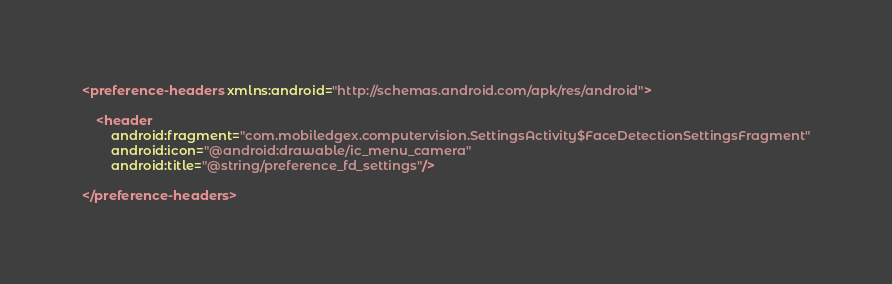<code> <loc_0><loc_0><loc_500><loc_500><_XML_><preference-headers xmlns:android="http://schemas.android.com/apk/res/android">

    <header
        android:fragment="com.mobiledgex.computervision.SettingsActivity$FaceDetectionSettingsFragment"
        android:icon="@android:drawable/ic_menu_camera"
        android:title="@string/preference_fd_settings"/>

</preference-headers>
</code> 